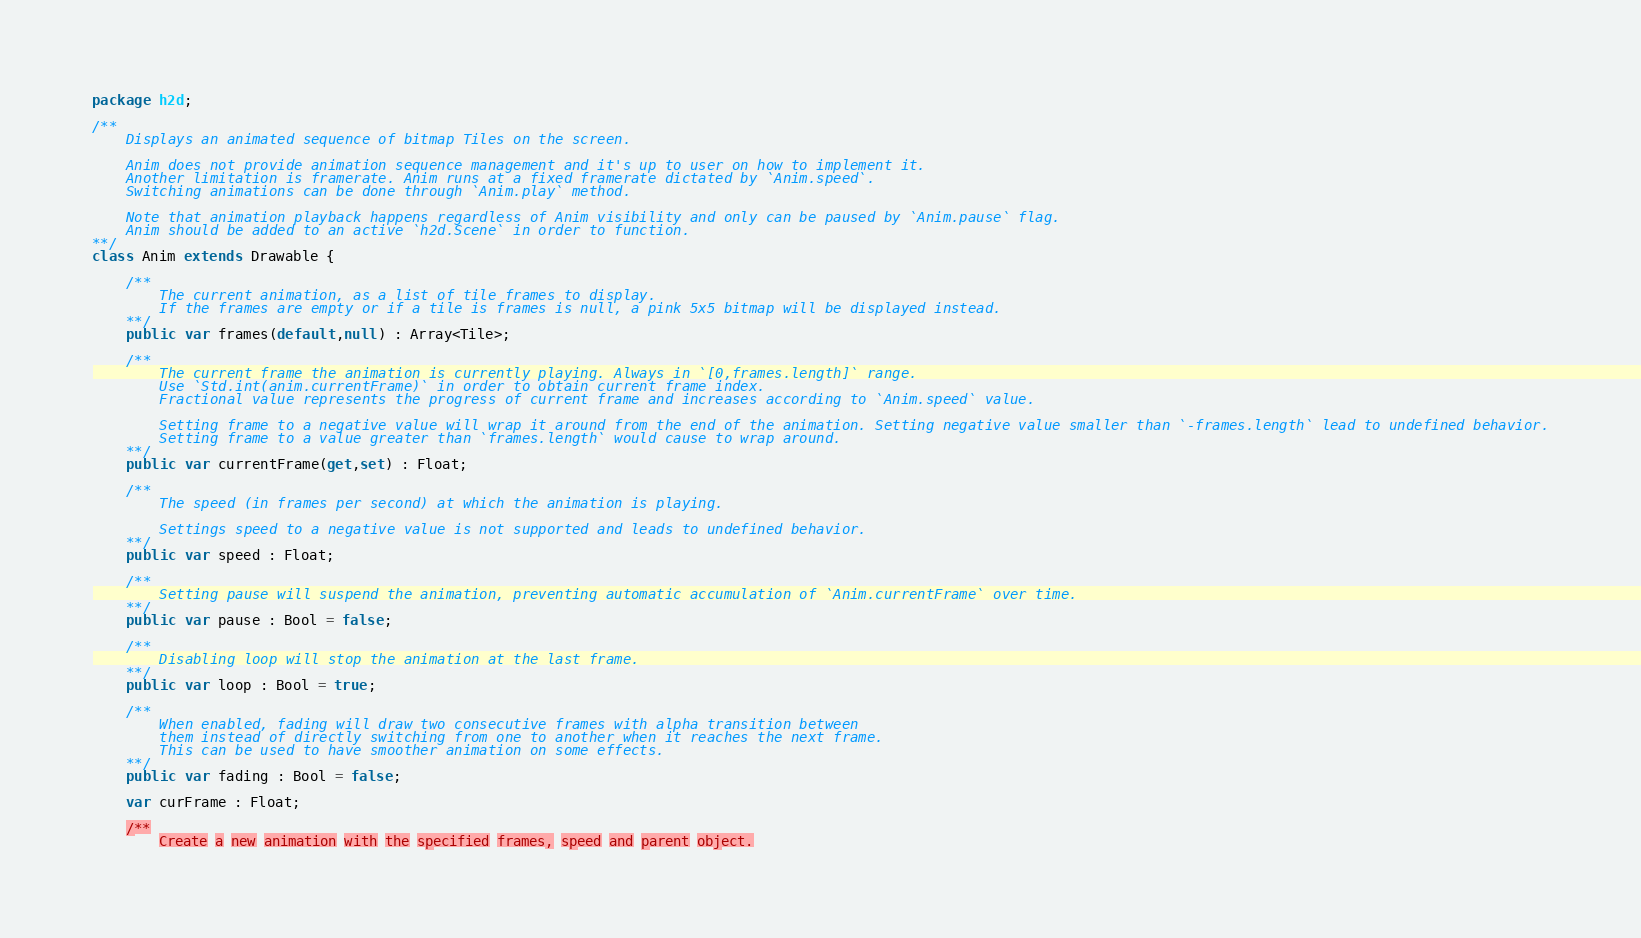Convert code to text. <code><loc_0><loc_0><loc_500><loc_500><_Haxe_>package h2d;

/**
	Displays an animated sequence of bitmap Tiles on the screen.

	Anim does not provide animation sequence management and it's up to user on how to implement it.
	Another limitation is framerate. Anim runs at a fixed framerate dictated by `Anim.speed`.
	Switching animations can be done through `Anim.play` method.

	Note that animation playback happens regardless of Anim visibility and only can be paused by `Anim.pause` flag. 
	Anim should be added to an active `h2d.Scene` in order to function.
**/
class Anim extends Drawable {

	/**
		The current animation, as a list of tile frames to display.
		If the frames are empty or if a tile is frames is null, a pink 5x5 bitmap will be displayed instead.
	**/
	public var frames(default,null) : Array<Tile>;

	/**
		The current frame the animation is currently playing. Always in `[0,frames.length]` range.
		Use `Std.int(anim.currentFrame)` in order to obtain current frame index.
		Fractional value represents the progress of current frame and increases according to `Anim.speed` value.

		Setting frame to a negative value will wrap it around from the end of the animation. Setting negative value smaller than `-frames.length` lead to undefined behavior.
		Setting frame to a value greater than `frames.length` would cause to wrap around.
	**/
	public var currentFrame(get,set) : Float;

	/**
		The speed (in frames per second) at which the animation is playing.

		Settings speed to a negative value is not supported and leads to undefined behavior.
	**/
	public var speed : Float;

	/**
		Setting pause will suspend the animation, preventing automatic accumulation of `Anim.currentFrame` over time.
	**/
	public var pause : Bool = false;

	/**
		Disabling loop will stop the animation at the last frame.
	**/
	public var loop : Bool = true;

	/**
		When enabled, fading will draw two consecutive frames with alpha transition between
		them instead of directly switching from one to another when it reaches the next frame.
		This can be used to have smoother animation on some effects.
	**/
	public var fading : Bool = false;

	var curFrame : Float;

	/**
		Create a new animation with the specified frames, speed and parent object.</code> 